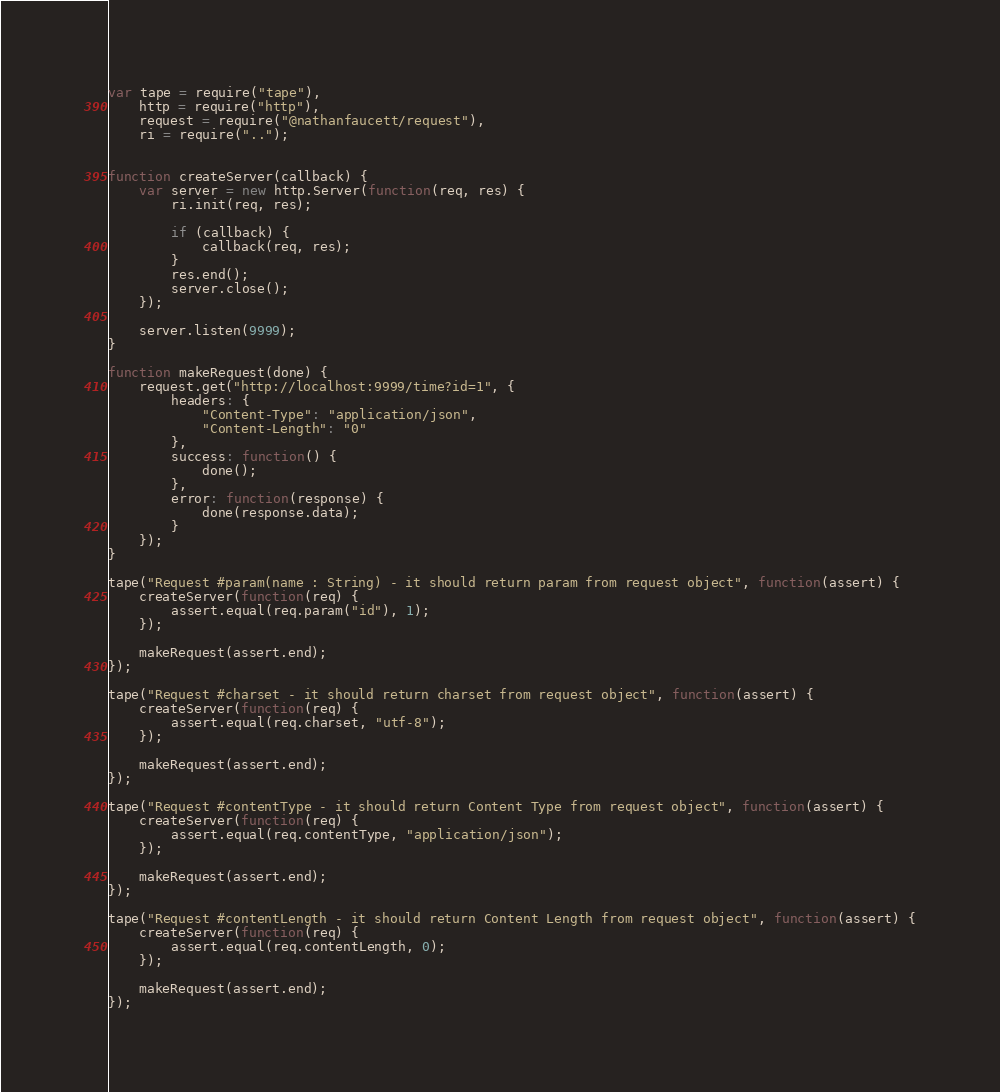<code> <loc_0><loc_0><loc_500><loc_500><_JavaScript_>var tape = require("tape"),
    http = require("http"),
    request = require("@nathanfaucett/request"),
    ri = require("..");


function createServer(callback) {
    var server = new http.Server(function(req, res) {
        ri.init(req, res);

        if (callback) {
            callback(req, res);
        }
        res.end();
        server.close();
    });

    server.listen(9999);
}

function makeRequest(done) {
    request.get("http://localhost:9999/time?id=1", {
        headers: {
            "Content-Type": "application/json",
            "Content-Length": "0"
        },
        success: function() {
            done();
        },
        error: function(response) {
            done(response.data);
        }
    });
}

tape("Request #param(name : String) - it should return param from request object", function(assert) {
    createServer(function(req) {
        assert.equal(req.param("id"), 1);
    });

    makeRequest(assert.end);
});

tape("Request #charset - it should return charset from request object", function(assert) {
    createServer(function(req) {
        assert.equal(req.charset, "utf-8");
    });

    makeRequest(assert.end);
});

tape("Request #contentType - it should return Content Type from request object", function(assert) {
    createServer(function(req) {
        assert.equal(req.contentType, "application/json");
    });

    makeRequest(assert.end);
});

tape("Request #contentLength - it should return Content Length from request object", function(assert) {
    createServer(function(req) {
        assert.equal(req.contentLength, 0);
    });

    makeRequest(assert.end);
});
</code> 